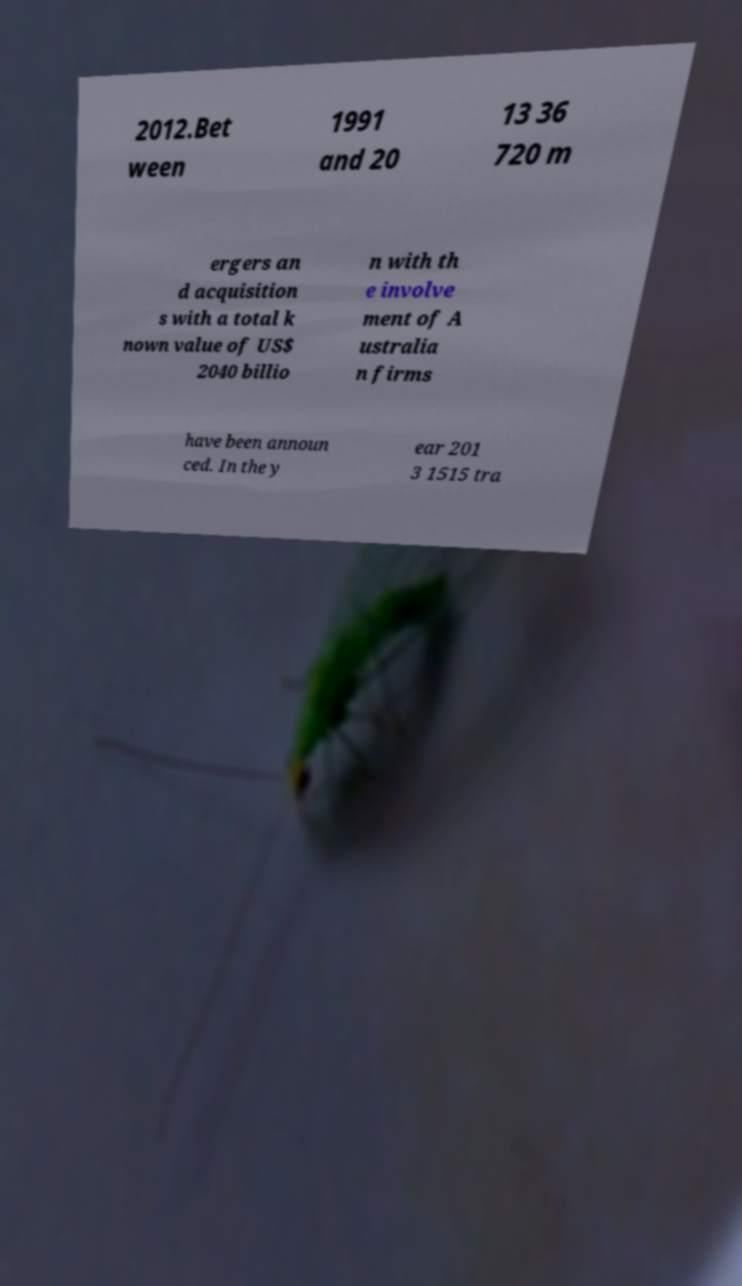Please identify and transcribe the text found in this image. 2012.Bet ween 1991 and 20 13 36 720 m ergers an d acquisition s with a total k nown value of US$ 2040 billio n with th e involve ment of A ustralia n firms have been announ ced. In the y ear 201 3 1515 tra 